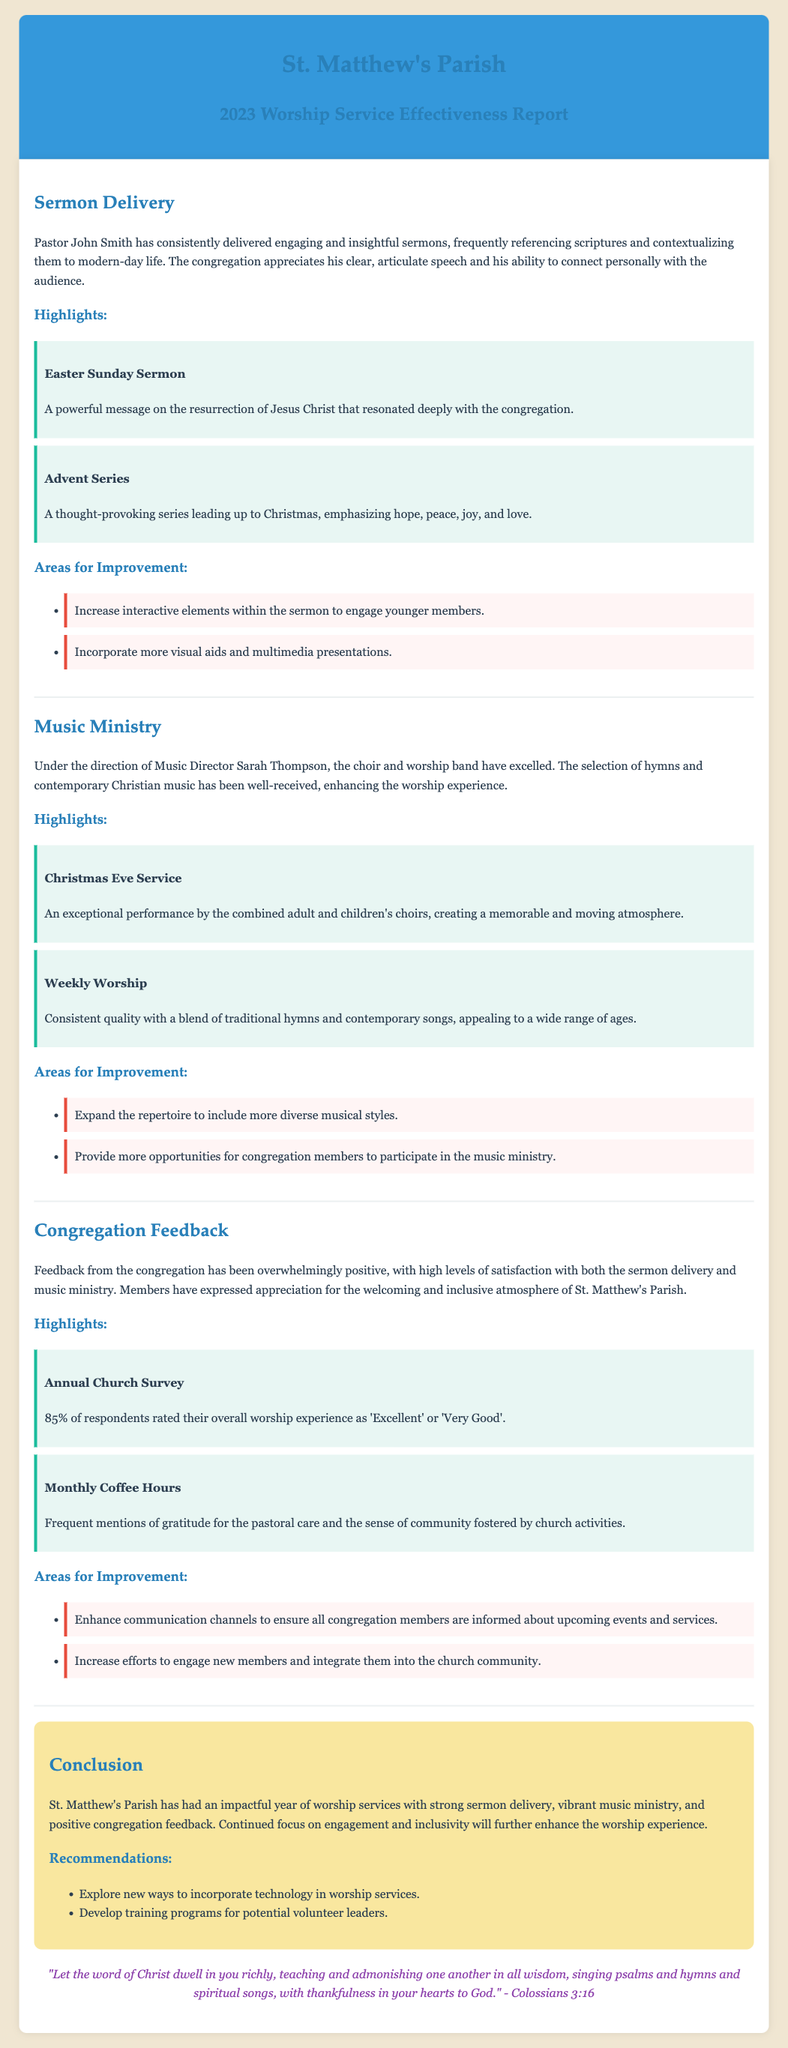What is the name of the pastor? The name of the pastor mentioned in the document is Pastor John Smith.
Answer: Pastor John Smith What percentage of respondents rated their worship experience as 'Excellent' or 'Very Good'? The document states that 85% of respondents rated their experience positively.
Answer: 85% Which event featured a powerful message on the resurrection of Jesus Christ? The Easter Sunday Sermon is highlighted as having a powerful message on the resurrection.
Answer: Easter Sunday Sermon What innovative suggestion is proposed for sermon delivery? It is suggested to increase interactive elements within the sermon to engage younger members.
Answer: Increase interactive elements What is the role of Sarah Thompson in the worship service? Sarah Thompson is the Music Director overseeing the choir and worship band.
Answer: Music Director What was the highlight of the Christmas Eve Service? The exceptional performance by the combined adult and children's choirs is noted as a highlight.
Answer: Exceptional performance What are two recommendations from the conclusion? The document suggests exploring new technology in worship services and developing training programs for leaders.
Answer: Explore new technology; develop training programs What aspect of the music ministry received positive feedback? The selection of hymns and contemporary Christian music enhancing the worship experience was positively noted.
Answer: Selection of hymns and contemporary music What is one way to enhance communication with congregation members? The document mentions enhancing communication channels to inform members about events and services.
Answer: Enhance communication channels 